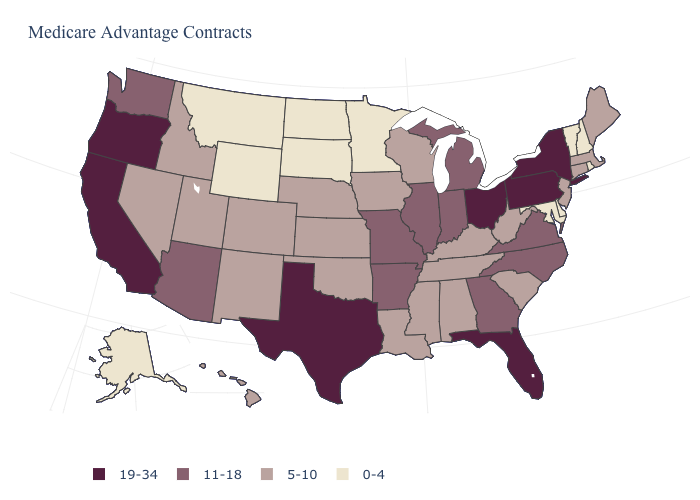Among the states that border Michigan , does Ohio have the lowest value?
Short answer required. No. How many symbols are there in the legend?
Be succinct. 4. Name the states that have a value in the range 5-10?
Give a very brief answer. Alabama, Colorado, Connecticut, Hawaii, Iowa, Idaho, Kansas, Kentucky, Louisiana, Massachusetts, Maine, Mississippi, Nebraska, New Jersey, New Mexico, Nevada, Oklahoma, South Carolina, Tennessee, Utah, Wisconsin, West Virginia. What is the highest value in states that border New Jersey?
Quick response, please. 19-34. What is the highest value in states that border Kentucky?
Short answer required. 19-34. Which states have the highest value in the USA?
Answer briefly. California, Florida, New York, Ohio, Oregon, Pennsylvania, Texas. Among the states that border Utah , does Arizona have the lowest value?
Write a very short answer. No. What is the value of Ohio?
Quick response, please. 19-34. Among the states that border Colorado , which have the highest value?
Keep it brief. Arizona. Does Utah have the highest value in the USA?
Be succinct. No. Name the states that have a value in the range 11-18?
Concise answer only. Arkansas, Arizona, Georgia, Illinois, Indiana, Michigan, Missouri, North Carolina, Virginia, Washington. What is the value of North Dakota?
Write a very short answer. 0-4. What is the value of Pennsylvania?
Keep it brief. 19-34. Name the states that have a value in the range 5-10?
Answer briefly. Alabama, Colorado, Connecticut, Hawaii, Iowa, Idaho, Kansas, Kentucky, Louisiana, Massachusetts, Maine, Mississippi, Nebraska, New Jersey, New Mexico, Nevada, Oklahoma, South Carolina, Tennessee, Utah, Wisconsin, West Virginia. 